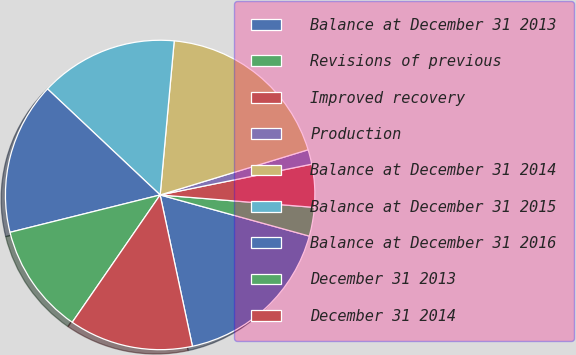<chart> <loc_0><loc_0><loc_500><loc_500><pie_chart><fcel>Balance at December 31 2013<fcel>Revisions of previous<fcel>Improved recovery<fcel>Production<fcel>Balance at December 31 2014<fcel>Balance at December 31 2015<fcel>Balance at December 31 2016<fcel>December 31 2013<fcel>December 31 2014<nl><fcel>17.37%<fcel>3.0%<fcel>4.47%<fcel>1.53%<fcel>18.83%<fcel>14.43%<fcel>15.9%<fcel>11.5%<fcel>12.96%<nl></chart> 